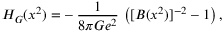<formula> <loc_0><loc_0><loc_500><loc_500>H _ { G } ( x ^ { 2 } ) = - \, { \frac { 1 } { 8 \pi G e ^ { 2 } } } \, \left ( [ B ( x ^ { 2 } ) ] ^ { - 2 } - 1 \right ) ,</formula> 